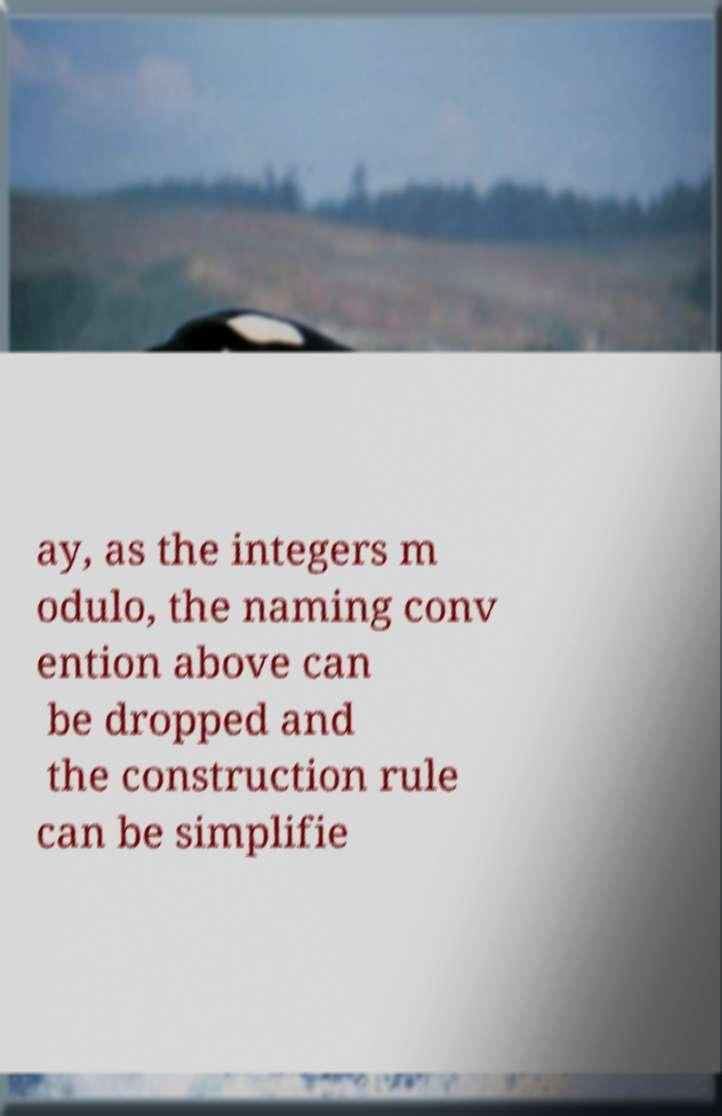I need the written content from this picture converted into text. Can you do that? ay, as the integers m odulo, the naming conv ention above can be dropped and the construction rule can be simplifie 